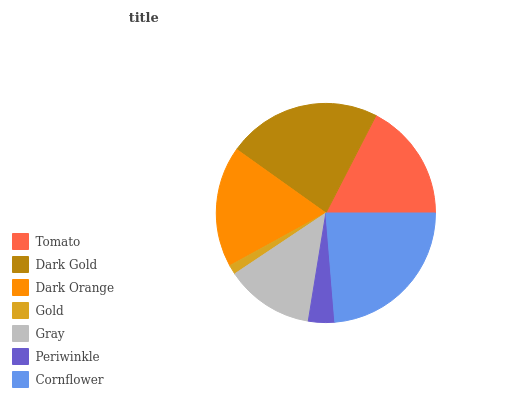Is Gold the minimum?
Answer yes or no. Yes. Is Cornflower the maximum?
Answer yes or no. Yes. Is Dark Gold the minimum?
Answer yes or no. No. Is Dark Gold the maximum?
Answer yes or no. No. Is Dark Gold greater than Tomato?
Answer yes or no. Yes. Is Tomato less than Dark Gold?
Answer yes or no. Yes. Is Tomato greater than Dark Gold?
Answer yes or no. No. Is Dark Gold less than Tomato?
Answer yes or no. No. Is Tomato the high median?
Answer yes or no. Yes. Is Tomato the low median?
Answer yes or no. Yes. Is Gold the high median?
Answer yes or no. No. Is Dark Gold the low median?
Answer yes or no. No. 